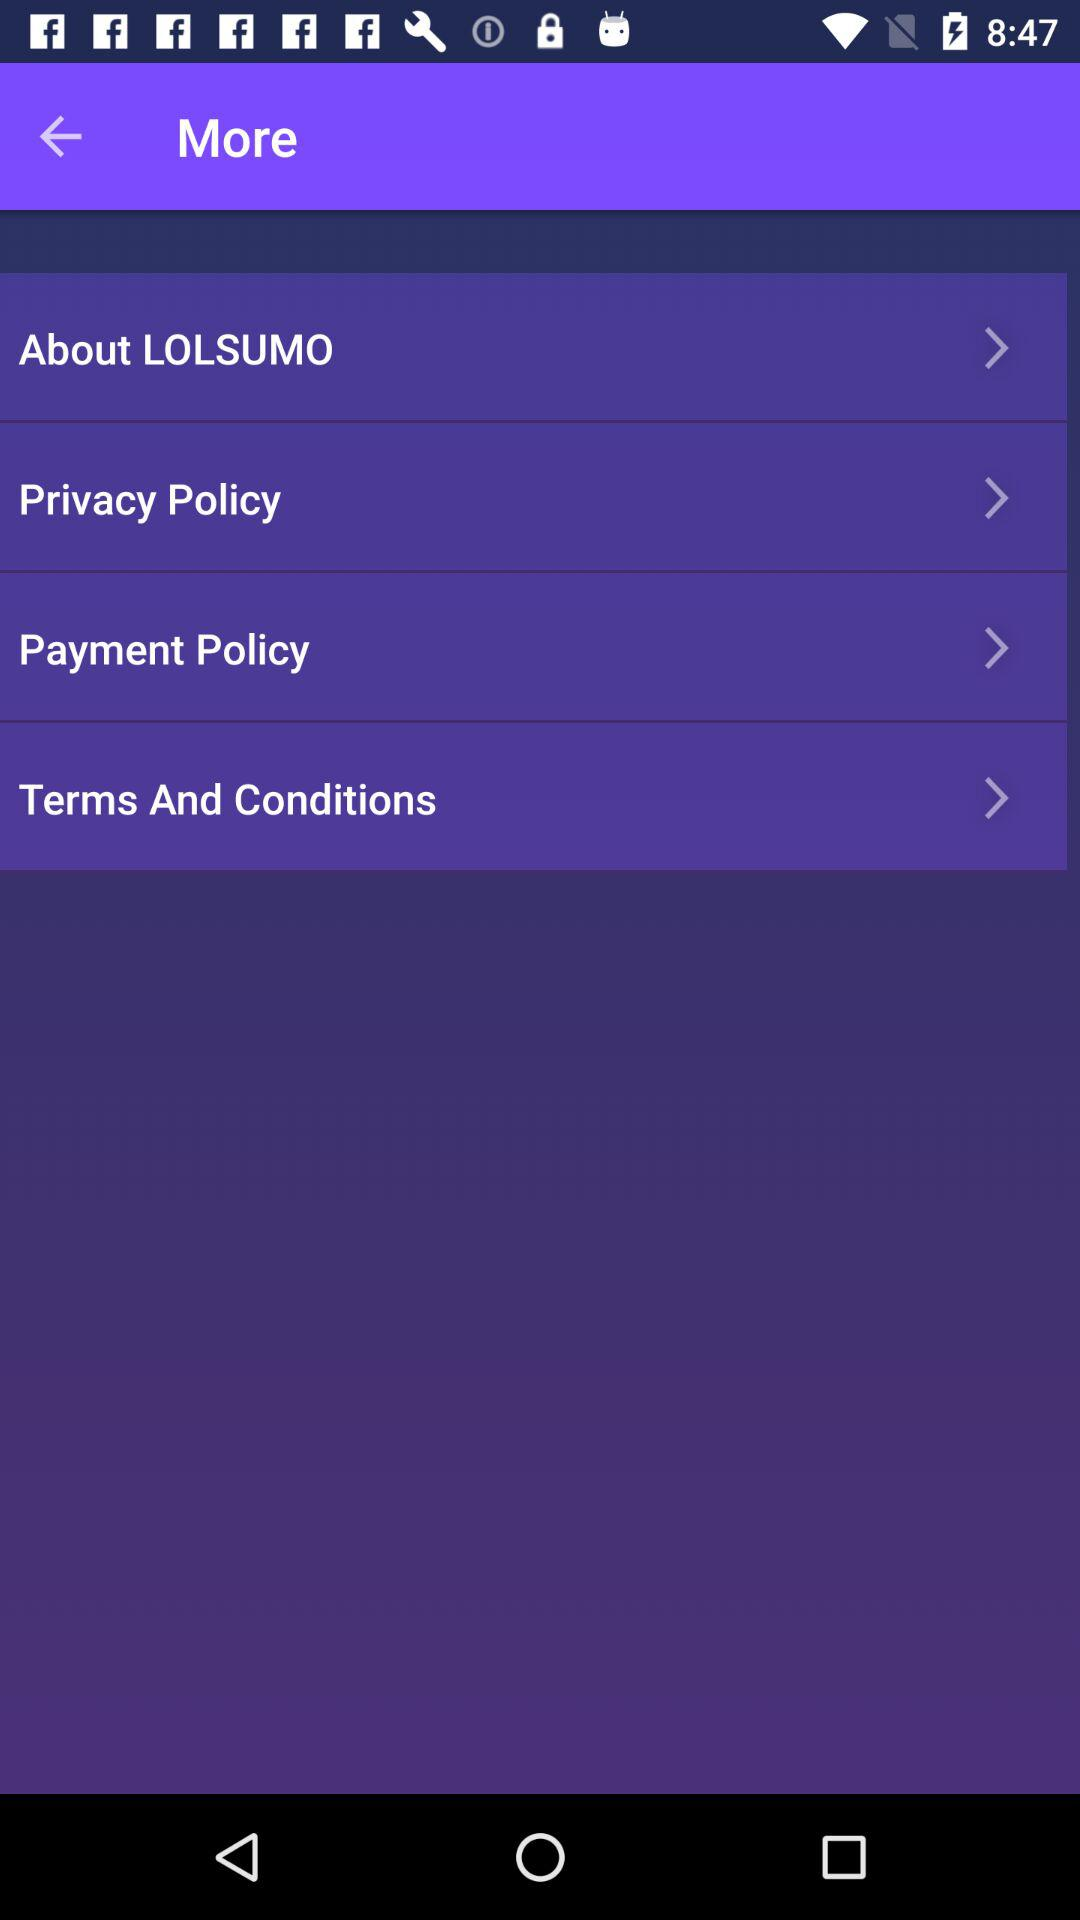What is the name of the application? The name of the application is "LOLSUMO". 